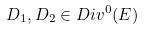Convert formula to latex. <formula><loc_0><loc_0><loc_500><loc_500>D _ { 1 } , D _ { 2 } \in D i v ^ { 0 } ( E )</formula> 